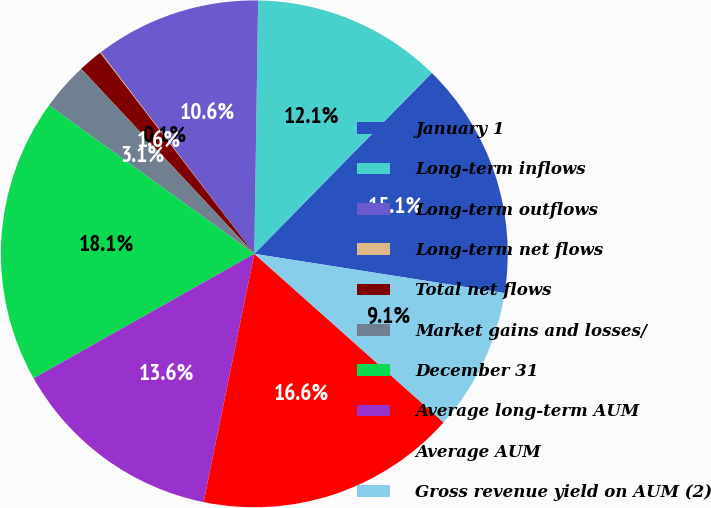Convert chart to OTSL. <chart><loc_0><loc_0><loc_500><loc_500><pie_chart><fcel>January 1<fcel>Long-term inflows<fcel>Long-term outflows<fcel>Long-term net flows<fcel>Total net flows<fcel>Market gains and losses/<fcel>December 31<fcel>Average long-term AUM<fcel>Average AUM<fcel>Gross revenue yield on AUM (2)<nl><fcel>15.13%<fcel>12.11%<fcel>10.6%<fcel>0.05%<fcel>1.56%<fcel>3.06%<fcel>18.14%<fcel>13.62%<fcel>16.63%<fcel>9.1%<nl></chart> 